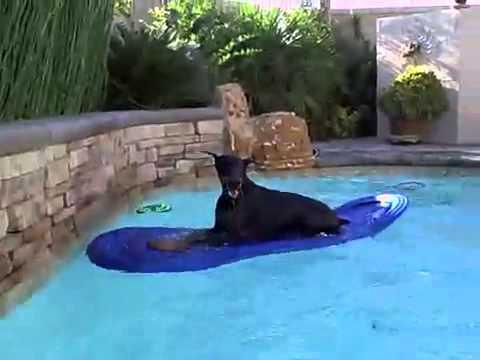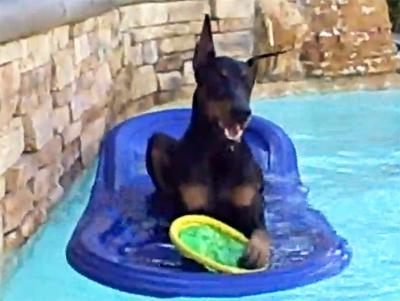The first image is the image on the left, the second image is the image on the right. Given the left and right images, does the statement "A man is in a pool interacting with a doberman in one image, and the other shows a doberman by itself in water." hold true? Answer yes or no. No. The first image is the image on the left, the second image is the image on the right. Assess this claim about the two images: "Both dogs are swimming in a pool and neither is sitting on a float.". Correct or not? Answer yes or no. No. 